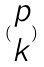<formula> <loc_0><loc_0><loc_500><loc_500>( \begin{matrix} p \\ k \end{matrix} )</formula> 